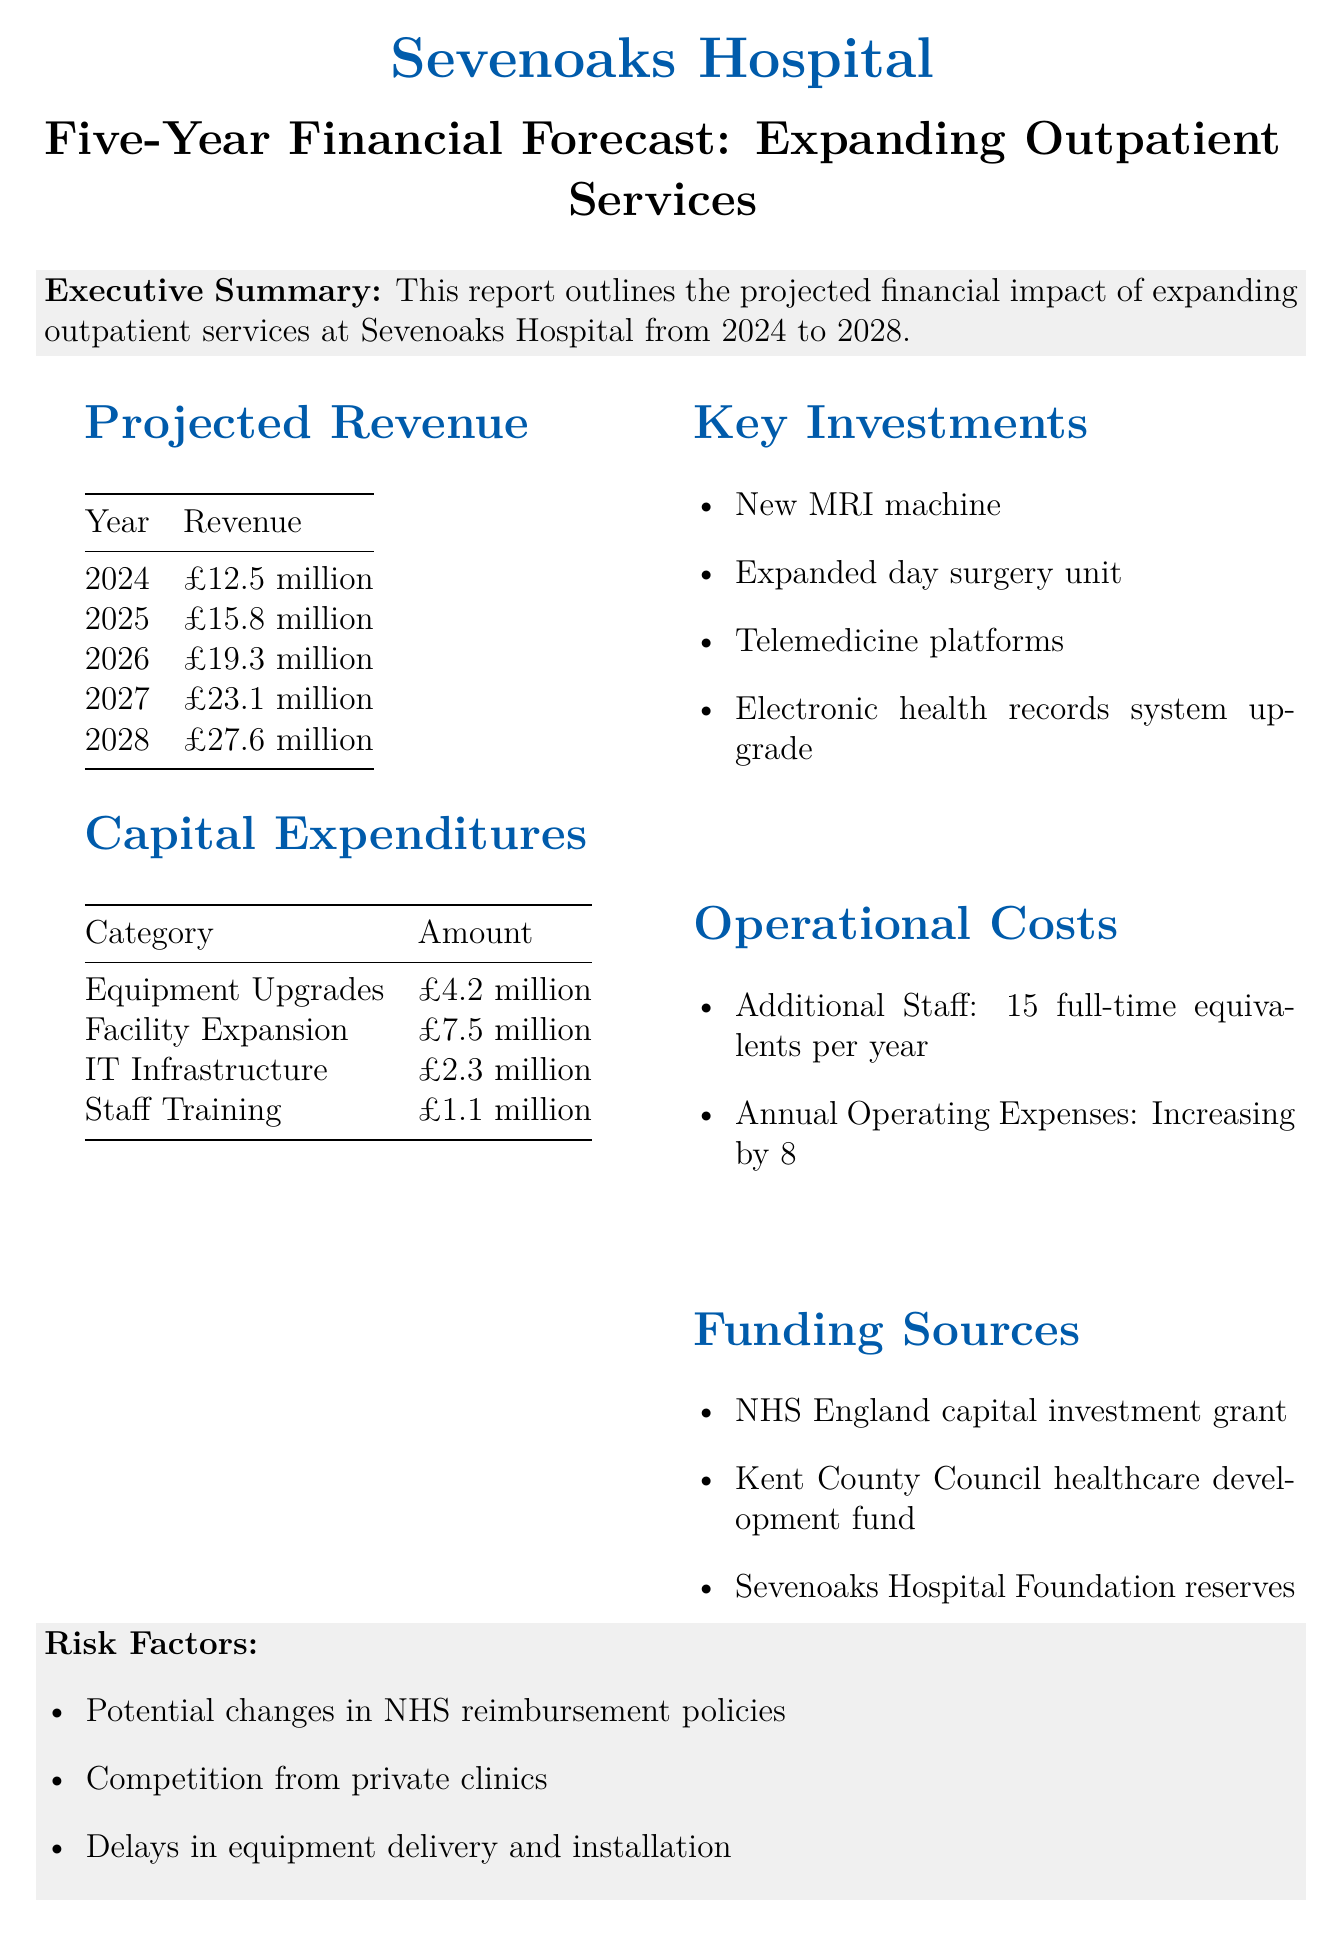What is the total projected revenue for 2028? The total projected revenue for 2028 is stated in the document under projected revenue.
Answer: £27.6 million What are the capital expenditures for IT infrastructure? The capital expenditures for IT infrastructure is clearly specified in the table of capital expenditures.
Answer: £2.3 million What is the payback period for the investment? The payback period is mentioned in the return on investment section of the document.
Answer: 4.5 years How many full-time equivalents are needed per year for additional staff? The document states the number of full-time equivalents needed for additional staff under operational costs.
Answer: 15 full-time equivalents per year What is one key investment mentioned in the report? The report lists key investments, and one of them can be identified.
Answer: New MRI machine What is the projected annual savings by 2028? The projected annual savings is specified in the return on investment section of the report.
Answer: £3.2 million by 2028 Which funding source is mentioned for NHS England? The document includes funding sources, one of which is related to NHS England.
Answer: NHS England capital investment grant What percentage increase is projected for annual operating expenses? The document specifies the percentage increase for annual operating expenses under operational costs.
Answer: 8% year-over-year 